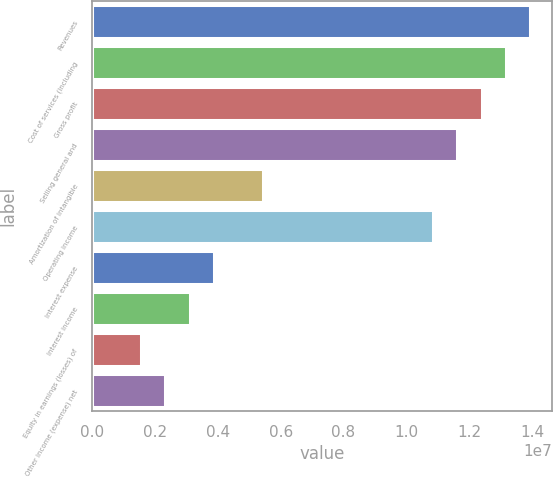<chart> <loc_0><loc_0><loc_500><loc_500><bar_chart><fcel>Revenues<fcel>Cost of services (including<fcel>Gross profit<fcel>Selling general and<fcel>Amortization of intangible<fcel>Operating income<fcel>Interest expense<fcel>Interest income<fcel>Equity in earnings (losses) of<fcel>Other income (expense) net<nl><fcel>1.3945e+07<fcel>1.31703e+07<fcel>1.23956e+07<fcel>1.16208e+07<fcel>5.42306e+06<fcel>1.08461e+07<fcel>3.87361e+06<fcel>3.09889e+06<fcel>1.54945e+06<fcel>2.32417e+06<nl></chart> 